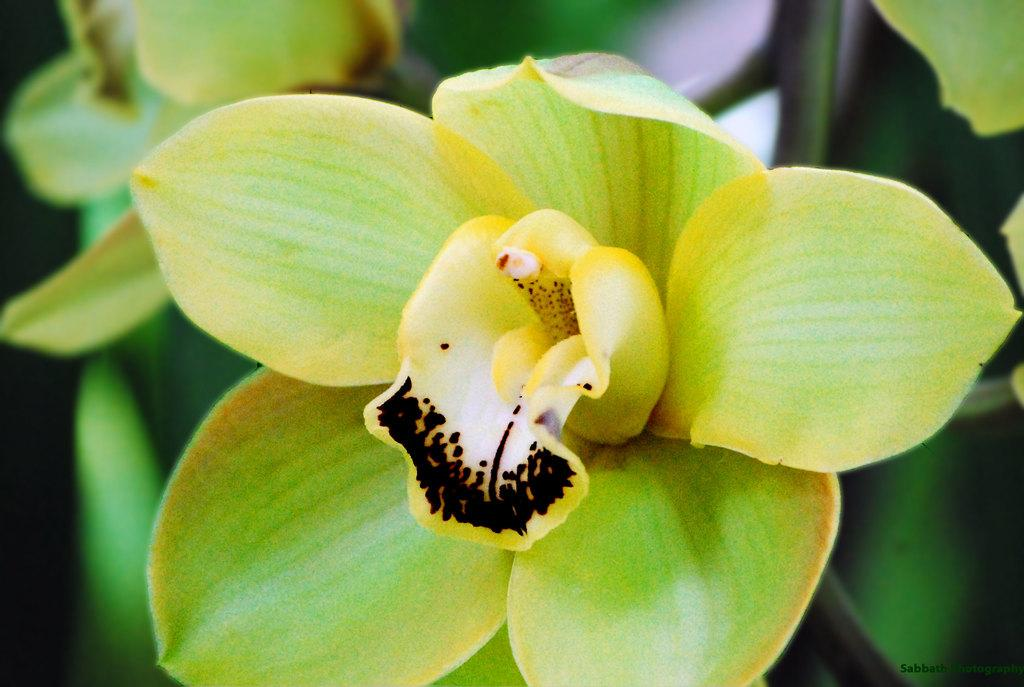What is the main subject of the image? There is a flower in the image. What can be seen in the background of the image? There are leaves in the background of the image. How would you describe the appearance of the background in the image? The background of the image is blurry. What is the profit margin of the flower in the image? There is no information about profit margins in the image, as it is a photograph and not a financial document. 